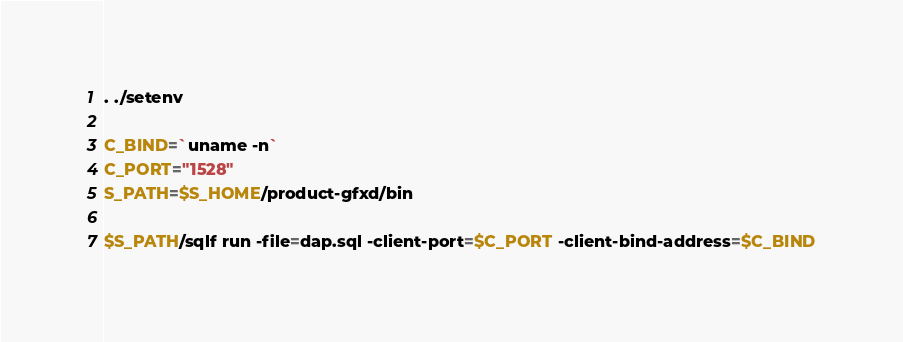<code> <loc_0><loc_0><loc_500><loc_500><_Bash_>
. ./setenv

C_BIND=`uname -n`
C_PORT="1528"
S_PATH=$S_HOME/product-gfxd/bin

$S_PATH/sqlf run -file=dap.sql -client-port=$C_PORT -client-bind-address=$C_BIND

</code> 